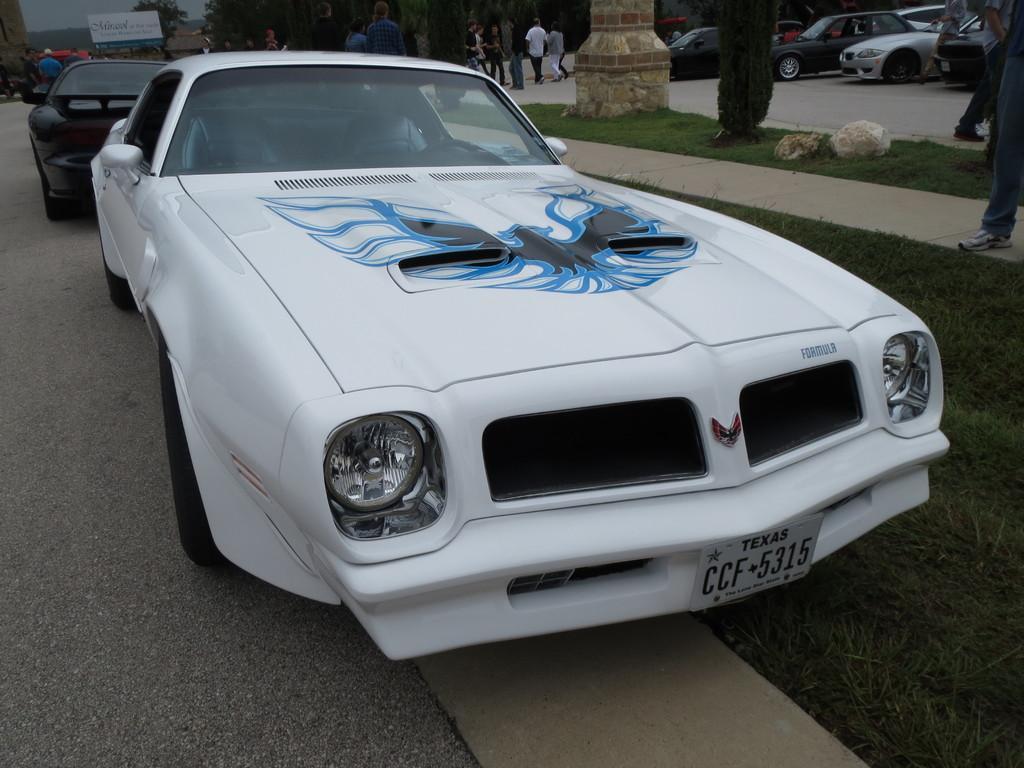Please provide a concise description of this image. We can see cars on the road and we can see people,grass,plants,stones and pillar. In the background we can see people,cars,trees,board and sky. 